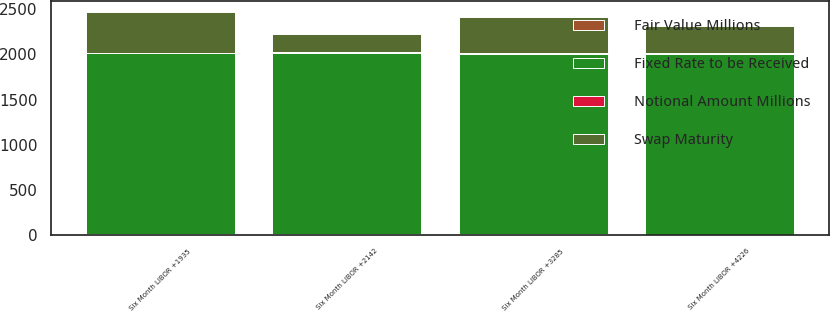<chart> <loc_0><loc_0><loc_500><loc_500><stacked_bar_chart><ecel><fcel>Six Month LIBOR +4226<fcel>Six Month LIBOR +1935<fcel>Six Month LIBOR +3285<fcel>Six Month LIBOR +2142<nl><fcel>Notional Amount Millions<fcel>6.65<fcel>5.38<fcel>6.85<fcel>6.12<nl><fcel>Swap Maturity<fcel>300<fcel>450<fcel>400<fcel>200<nl><fcel>Fixed Rate to be Received<fcel>2006<fcel>2007<fcel>2008<fcel>2012<nl><fcel>Fair Value Millions<fcel>1<fcel>6<fcel>3<fcel>6<nl></chart> 